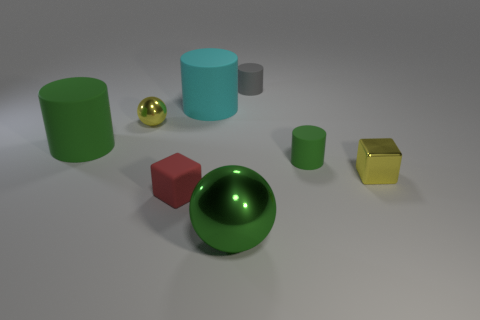What number of other cyan rubber objects are the same size as the cyan rubber object?
Your answer should be compact. 0. There is a small object that is the same color as the metal cube; what is its shape?
Ensure brevity in your answer.  Sphere. Are the big green object that is in front of the small green rubber cylinder and the yellow thing on the left side of the gray cylinder made of the same material?
Give a very brief answer. Yes. Are there any other things that have the same shape as the big metal thing?
Your answer should be very brief. Yes. What is the color of the small shiny ball?
Your answer should be very brief. Yellow. How many big green matte things have the same shape as the large cyan rubber object?
Offer a terse response. 1. There is a ball that is the same size as the cyan cylinder; what is its color?
Offer a terse response. Green. Are there any green matte cylinders?
Ensure brevity in your answer.  Yes. What shape is the small shiny object on the left side of the tiny gray thing?
Ensure brevity in your answer.  Sphere. What number of green objects are left of the tiny gray thing and to the right of the big green cylinder?
Your answer should be very brief. 1. 